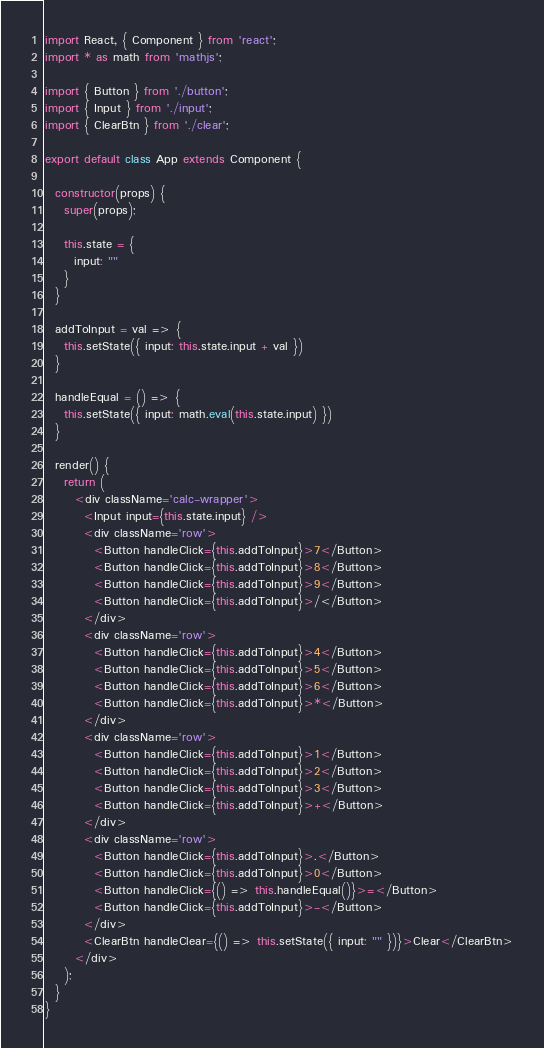<code> <loc_0><loc_0><loc_500><loc_500><_JavaScript_>import React, { Component } from 'react';
import * as math from 'mathjs';

import { Button } from './button';
import { Input } from './input';
import { ClearBtn } from './clear';

export default class App extends Component {

  constructor(props) {
    super(props);

    this.state = {
      input: ""
    }
  }

  addToInput = val => {
    this.setState({ input: this.state.input + val })
  }

  handleEqual = () => {
    this.setState({ input: math.eval(this.state.input) })
  }

  render() {
    return (
      <div className='calc-wrapper'>
        <Input input={this.state.input} />
        <div className='row'>
          <Button handleClick={this.addToInput}>7</Button>
          <Button handleClick={this.addToInput}>8</Button>
          <Button handleClick={this.addToInput}>9</Button>
          <Button handleClick={this.addToInput}>/</Button>
        </div>
        <div className='row'>
          <Button handleClick={this.addToInput}>4</Button>
          <Button handleClick={this.addToInput}>5</Button>
          <Button handleClick={this.addToInput}>6</Button>
          <Button handleClick={this.addToInput}>*</Button>
        </div>
        <div className='row'>
          <Button handleClick={this.addToInput}>1</Button>
          <Button handleClick={this.addToInput}>2</Button>
          <Button handleClick={this.addToInput}>3</Button>
          <Button handleClick={this.addToInput}>+</Button>
        </div>
        <div className='row'>
          <Button handleClick={this.addToInput}>.</Button>
          <Button handleClick={this.addToInput}>0</Button>
          <Button handleClick={() => this.handleEqual()}>=</Button>
          <Button handleClick={this.addToInput}>-</Button>
        </div>
        <ClearBtn handleClear={() => this.setState({ input: "" })}>Clear</ClearBtn>
      </div>
    );
  }
}
</code> 